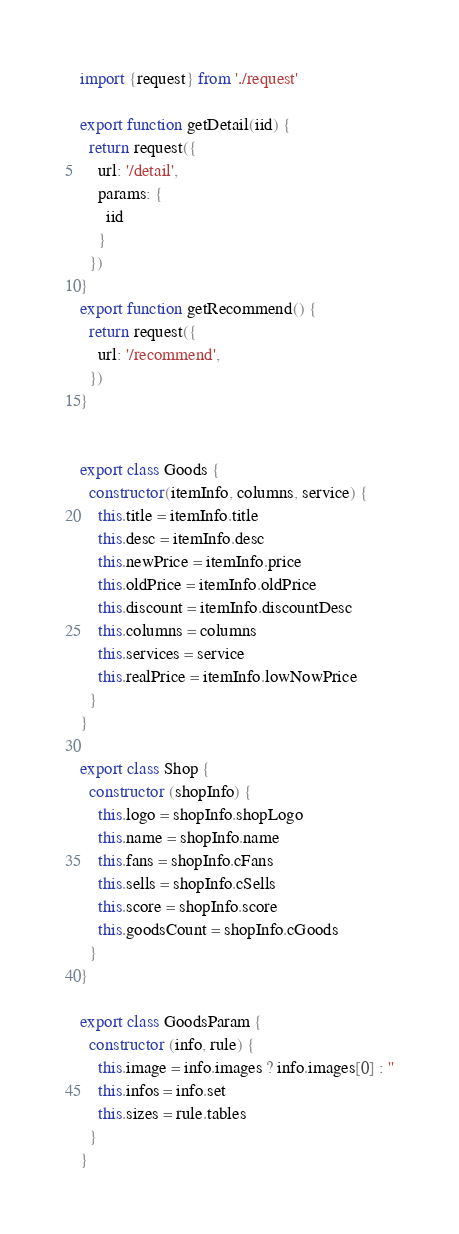Convert code to text. <code><loc_0><loc_0><loc_500><loc_500><_JavaScript_>import {request} from './request'

export function getDetail(iid) {
  return request({
    url: '/detail',
    params: {
      iid
    }
  })
}
export function getRecommend() {
  return request({
    url: '/recommend',
  })
}


export class Goods {
  constructor(itemInfo, columns, service) {
    this.title = itemInfo.title
    this.desc = itemInfo.desc
    this.newPrice = itemInfo.price
    this.oldPrice = itemInfo.oldPrice
    this.discount = itemInfo.discountDesc
    this.columns = columns
    this.services = service
    this.realPrice = itemInfo.lowNowPrice
  }
}

export class Shop {
  constructor (shopInfo) {
    this.logo = shopInfo.shopLogo
    this.name = shopInfo.name
    this.fans = shopInfo.cFans
    this.sells = shopInfo.cSells
    this.score = shopInfo.score
    this.goodsCount = shopInfo.cGoods
  }
}

export class GoodsParam {
  constructor (info, rule) {
    this.image = info.images ? info.images[0] : ''
    this.infos = info.set
    this.sizes = rule.tables
  }
}</code> 